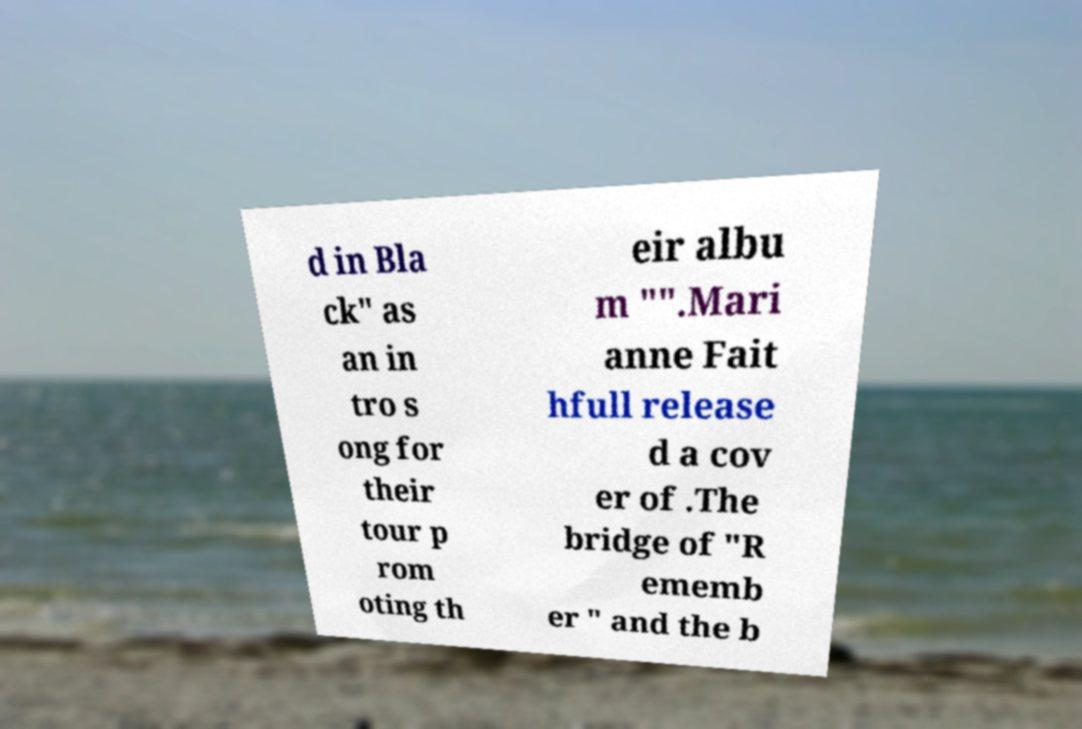Please read and relay the text visible in this image. What does it say? d in Bla ck" as an in tro s ong for their tour p rom oting th eir albu m "".Mari anne Fait hfull release d a cov er of .The bridge of "R ememb er " and the b 